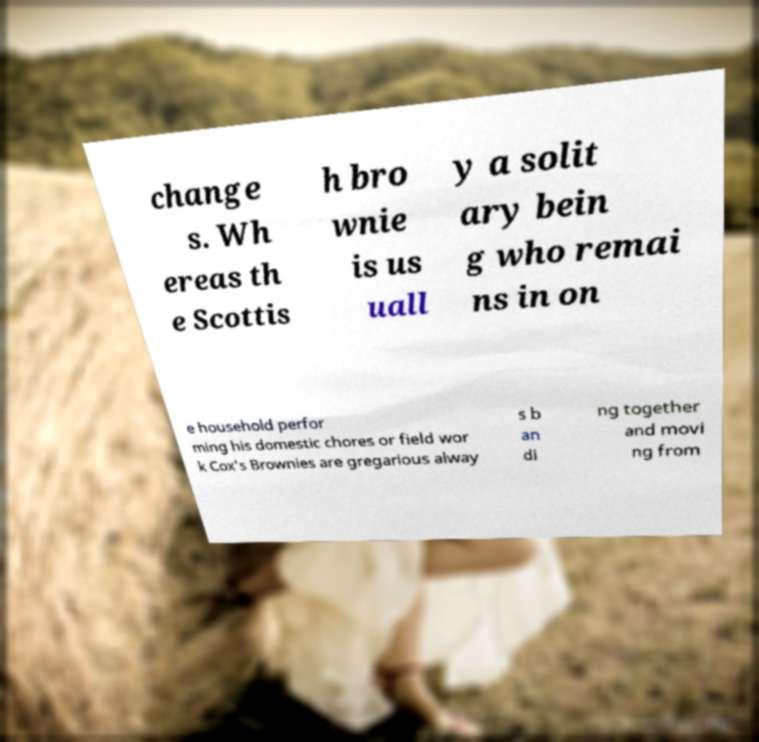Please identify and transcribe the text found in this image. change s. Wh ereas th e Scottis h bro wnie is us uall y a solit ary bein g who remai ns in on e household perfor ming his domestic chores or field wor k Cox's Brownies are gregarious alway s b an di ng together and movi ng from 